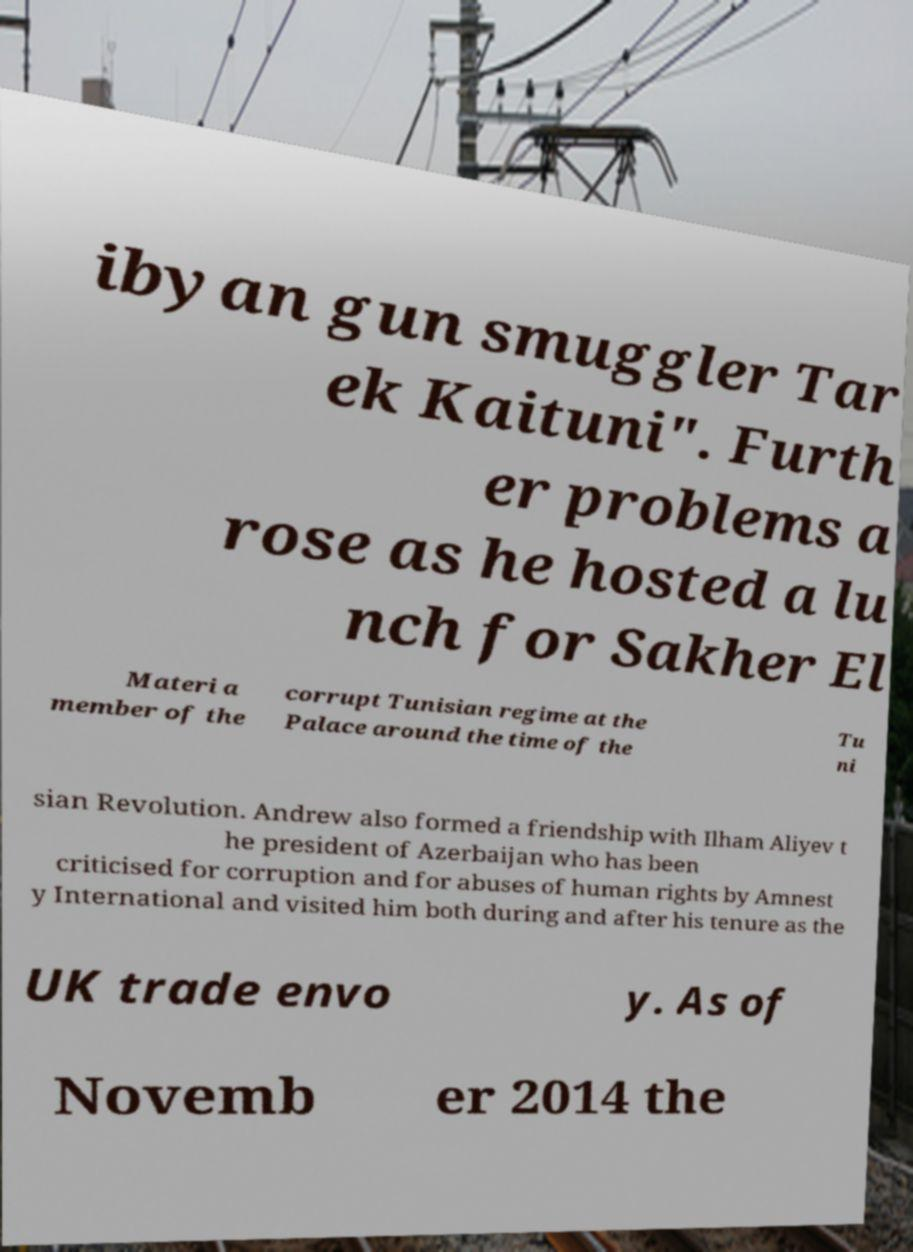Could you extract and type out the text from this image? ibyan gun smuggler Tar ek Kaituni". Furth er problems a rose as he hosted a lu nch for Sakher El Materi a member of the corrupt Tunisian regime at the Palace around the time of the Tu ni sian Revolution. Andrew also formed a friendship with Ilham Aliyev t he president of Azerbaijan who has been criticised for corruption and for abuses of human rights by Amnest y International and visited him both during and after his tenure as the UK trade envo y. As of Novemb er 2014 the 